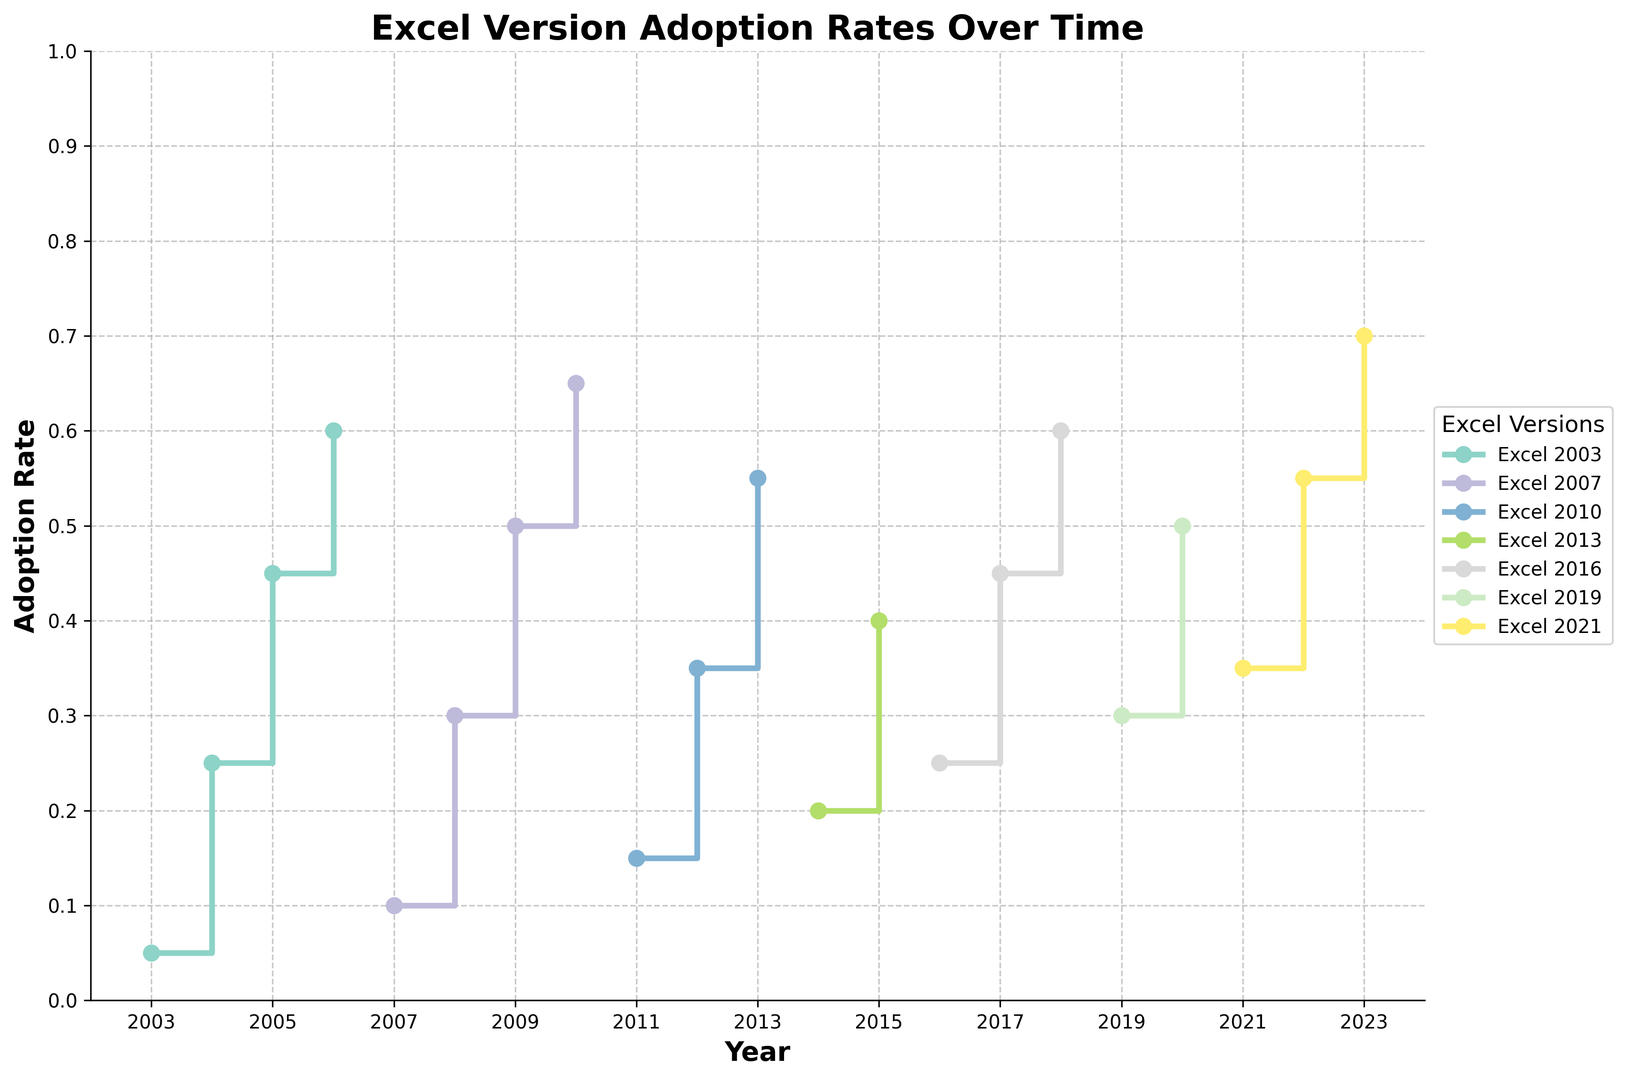What is the adoption rate of Excel 2007 in 2010? To find the adoption rate of Excel 2007 in 2010, locate the year 2010 on the x-axis and look for the corresponding value of Excel 2007 on the y-axis.
Answer: 0.65 Between which years did Excel 2010 see the highest increase in adoption rate? Review the adoption rates for Excel 2010 by comparing the y-values year by year. Identify the period during which the change is greatest.
Answer: 2011-2012 How does the adoption rate of Excel 2016 in 2018 compare to the adoption rate of Excel 2021 in 2023? Check the y-values for Excel 2016 in 2018 and Excel 2021 in 2023 on the plot and compare them.
Answer: Excel 2021 in 2023 is higher Which Excel version has the most extended period showing a continuous increase in adoption rates? Examine each version's trends for the longest period with a rising line, indicating an increase in adoption rate.
Answer: Excel 2016 What is the difference in adoption rates between Excel 2003 in 2005 and Excel 2007 in 2008? Identify the adoption rates for Excel 2003 in 2005 and Excel 2007 in 2008, then subtract to find the difference.
Answer: 0.15 Which two Excel versions have the closest adoption rates in the year 2012? Find the adoption rates for all Excel versions in 2012 and determine which two have the smallest difference.
Answer: Excel 2007 and Excel 2010 Which year did Excel 2019 start showing on the graph, and what was its initial adoption rate? Locate the first occurrence of Excel 2019 in the timeline and note the adoption rate at that point.
Answer: 2019, 0.30 In what year did Excel 2013 have an adoption rate of 0.40? Follow the y-axis line for 0.40 and see which year intersects with the line for Excel 2013.
Answer: 2015 What is the total increase in adoption rate for Excel 2021 from 2021 to 2023? Subtract the adoption rate of Excel 2021 in 2021 from its adoption rate in 2023 to find the total increase.
Answer: 0.35 Which Excel version had the highest adoption rate in 2020? Check the adoption rates for all versions in 2020 to see which is the highest.
Answer: Excel 2019 